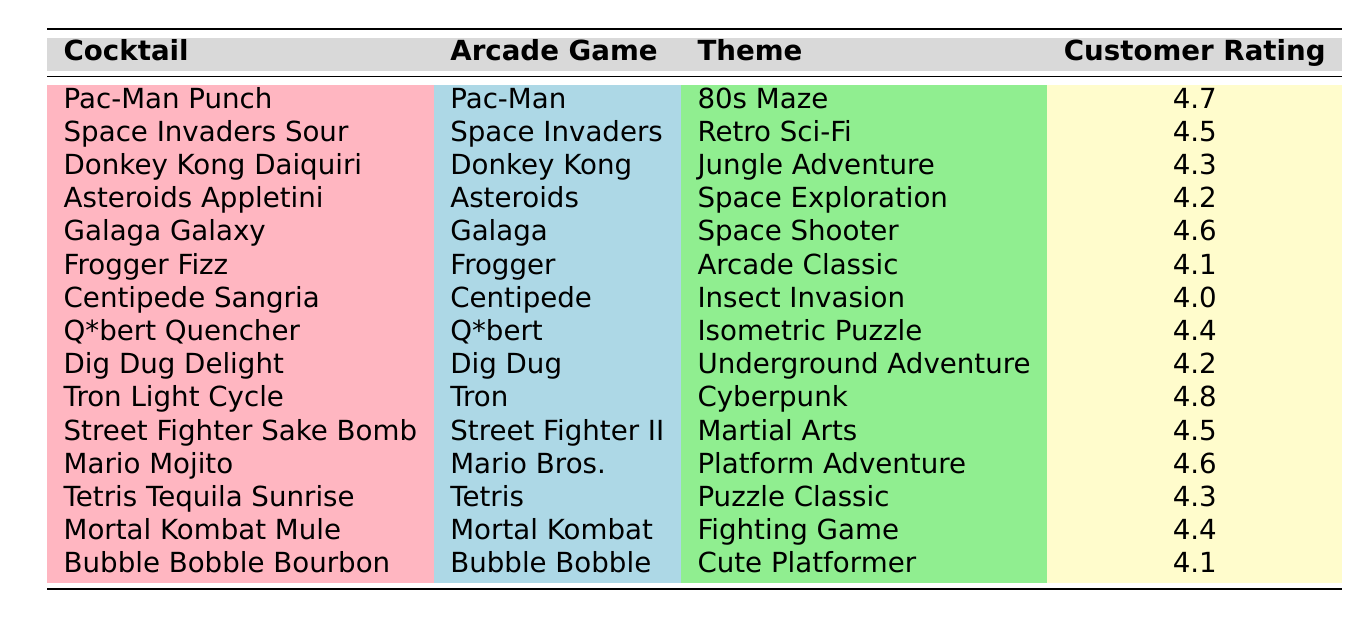What is the highest customer rating among the cocktails? The table lists customer ratings for various cocktails. By comparing each rating, we find that "Tron Light Cycle" has the highest rating of 4.8.
Answer: 4.8 Which cocktail has a lower rating: "Centipede Sangria" or "Frogger Fizz"? "Centipede Sangria" has a rating of 4.0 and "Frogger Fizz" has a rating of 4.1. Since 4.0 < 4.1, "Centipede Sangria" has the lower rating.
Answer: Centipede Sangria What is the average customer rating for cocktails themed around space? The relevant cocktails are "Asteroids Appletini" (4.2), "Galaga Galaxy" (4.6), and "Space Invaders Sour" (4.5). Their sum is 4.2 + 4.6 + 4.5 = 13.3. The average is 13.3 divided by 3, which is approximately 4.43.
Answer: 4.43 Is "Mario Mojito" rated higher than "Street Fighter Sake Bomb"? "Mario Mojito" has a rating of 4.6 and "Street Fighter Sake Bomb" has a rating of 4.5. Since 4.6 > 4.5, "Mario Mojito" is rated higher.
Answer: Yes What cocktail has the same rating as "Dig Dug Delight"? "Asteroids Appletini" also has a rating of 4.2, the same as "Dig Dug Delight".
Answer: Asteroids Appletini Which theme has the highest-rated cocktail, and what is the cocktail? The "Cyberpunk" theme has the highest-rated cocktail, which is "Tron Light Cycle" with a rating of 4.8.
Answer: Cyberpunk, Tron Light Cycle How many cocktails have a customer rating above 4.4? The cocktails above 4.4 are "Pac-Man Punch" (4.7), "Galaga Galaxy" (4.6), "Mario Mojito" (4.6), "Tron Light Cycle" (4.8), and "Street Fighter Sake Bomb" (4.5), totaling 5 cocktails.
Answer: 5 Are there more cocktails themed around adventure than those themed around fighting games? The adventure-themed cocktails are "Donkey Kong Daiquiri", "Dig Dug Delight", and "Mario Mojito", totaling 3. The fighting-themed cocktail is "Mortal Kombat Mule", so there is 1. Hence, there are more adventure cocktails than fighting games.
Answer: Yes What is the difference between the highest and lowest ratings? The highest rating is 4.8 and the lowest is 4.0. The difference is 4.8 - 4.0 = 0.8.
Answer: 0.8 Which arcade game corresponds with the cocktail "Frogger Fizz"? According to the table, "Frogger Fizz" corresponds with the arcade game "Frogger".
Answer: Frogger 